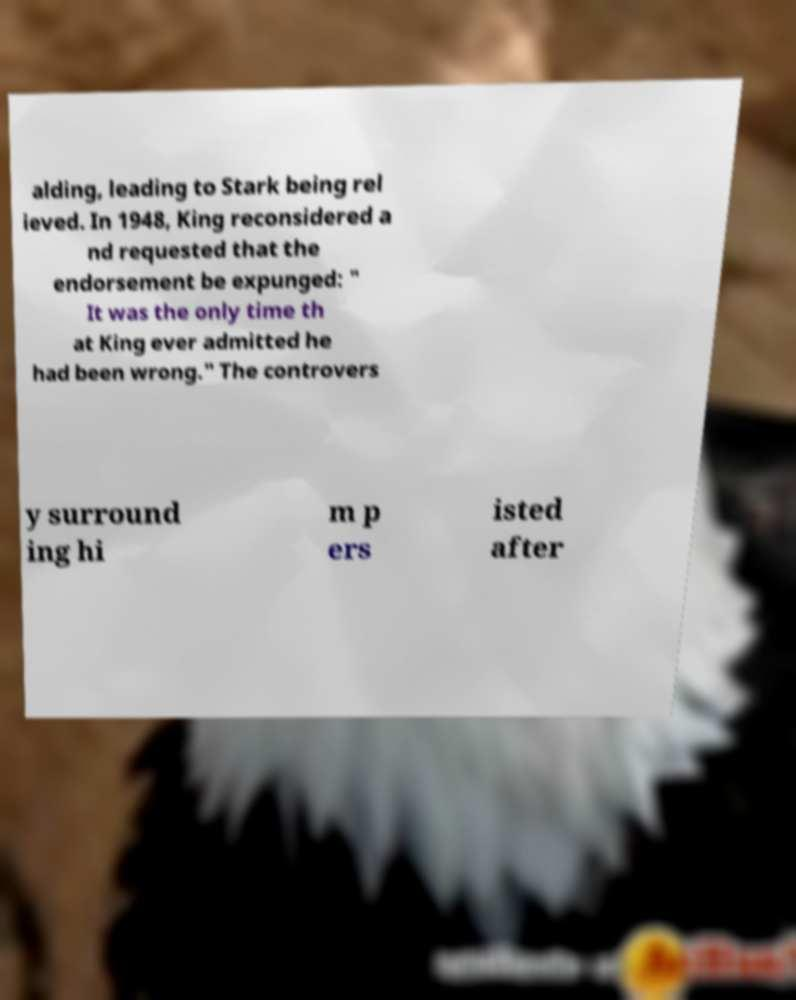I need the written content from this picture converted into text. Can you do that? alding, leading to Stark being rel ieved. In 1948, King reconsidered a nd requested that the endorsement be expunged: " It was the only time th at King ever admitted he had been wrong." The controvers y surround ing hi m p ers isted after 